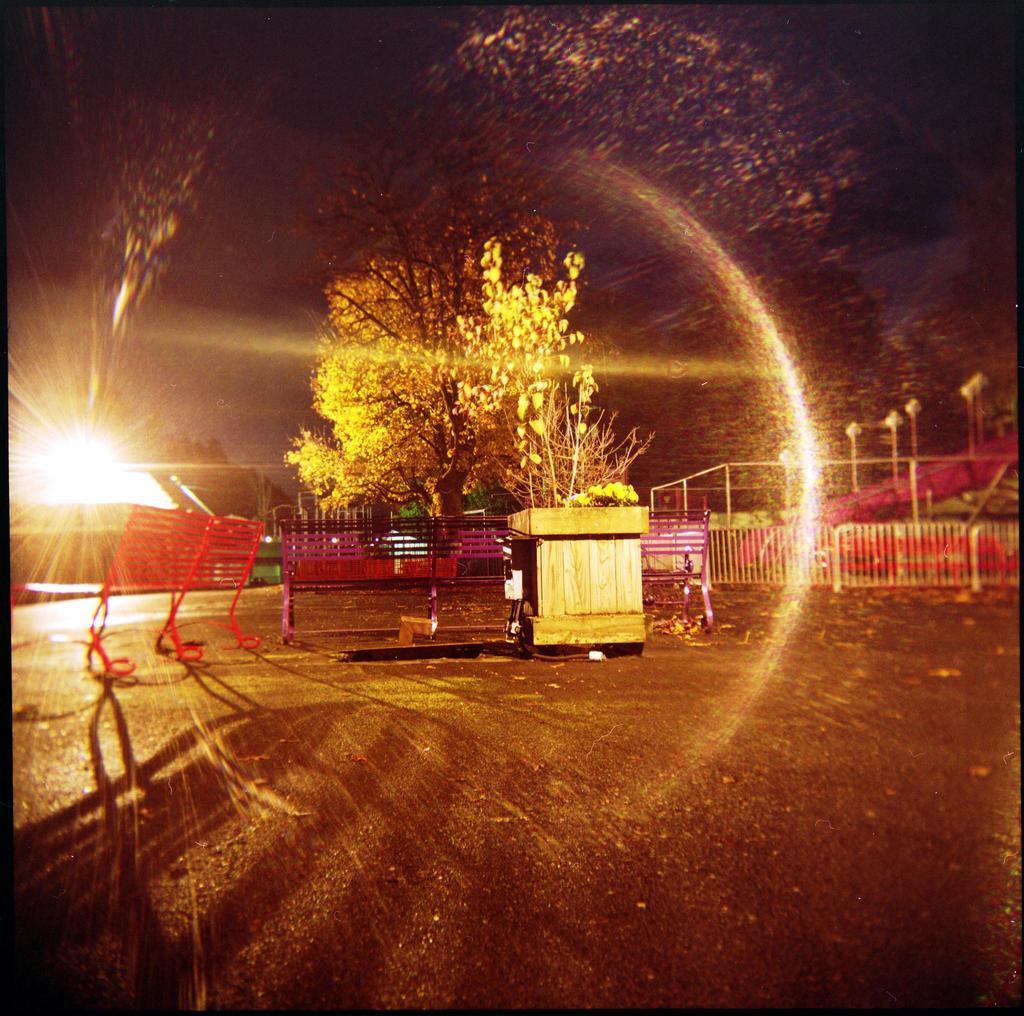Please provide a concise description of this image. In this image I see the ground on which there are benches over here and I see the fencing over here. In the background I see number of trees and I see the poles over here and I see that it is a bit dark and I see the light over here. 